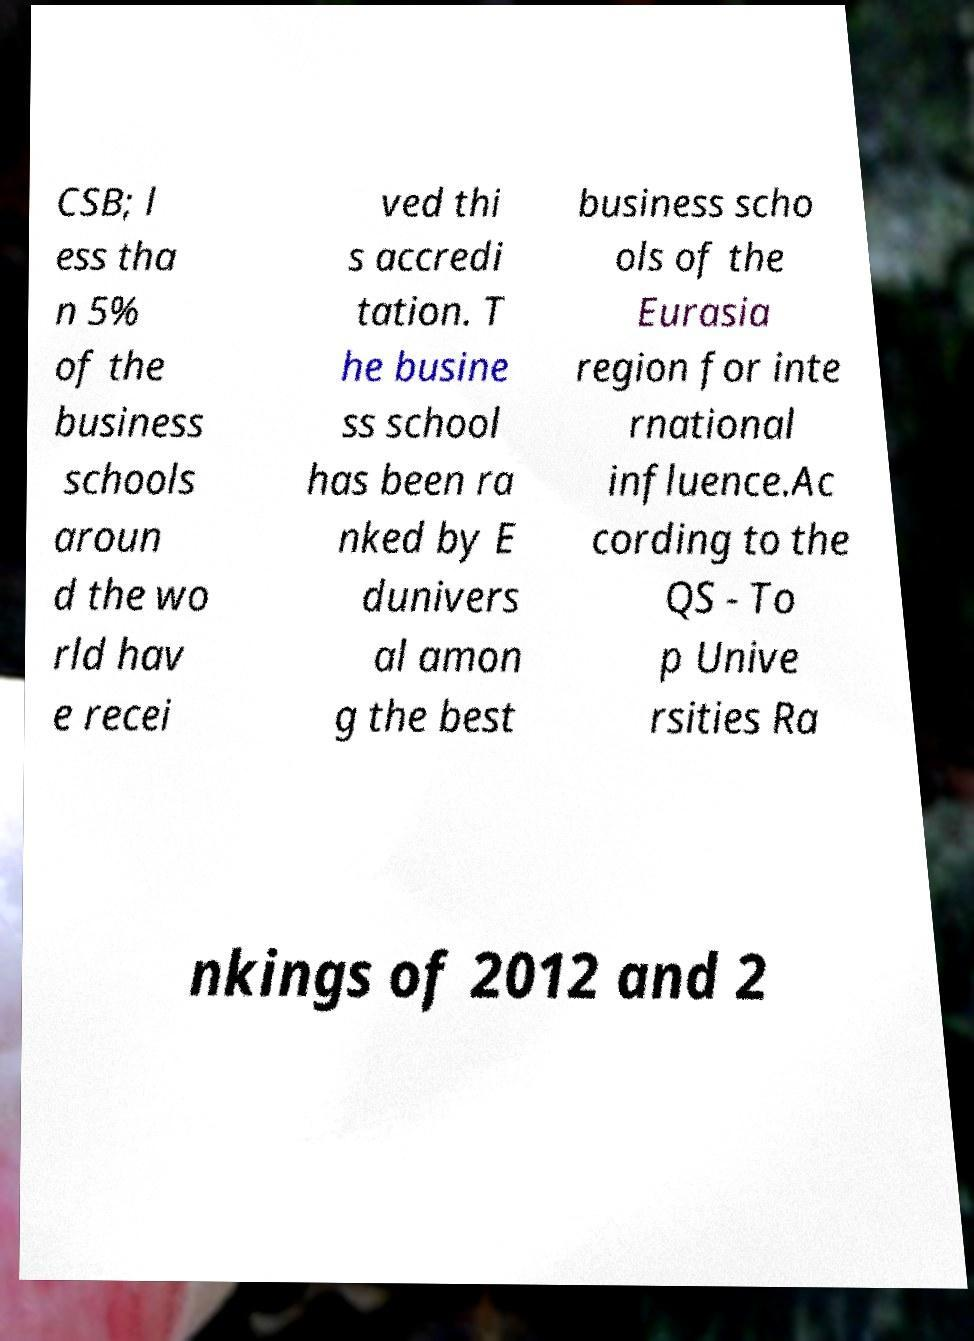Can you accurately transcribe the text from the provided image for me? CSB; l ess tha n 5% of the business schools aroun d the wo rld hav e recei ved thi s accredi tation. T he busine ss school has been ra nked by E dunivers al amon g the best business scho ols of the Eurasia region for inte rnational influence.Ac cording to the QS - To p Unive rsities Ra nkings of 2012 and 2 